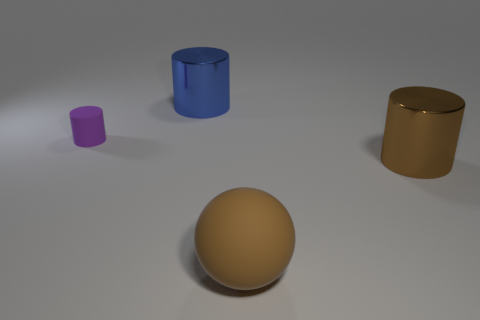What number of objects are either tiny purple cylinders or matte spheres? There are a total of two objects that meet the criteria: one tiny purple cylinder and one matte sphere. 